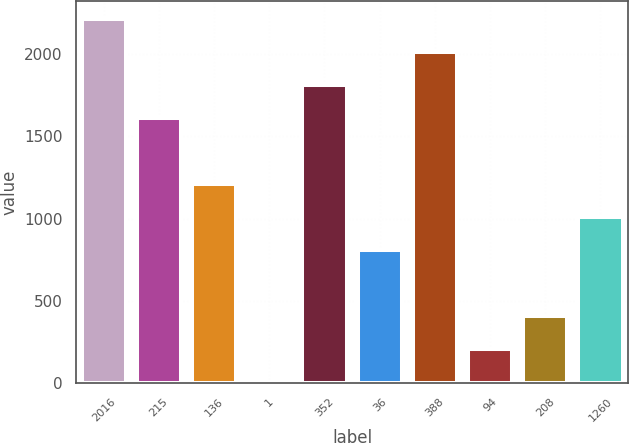<chart> <loc_0><loc_0><loc_500><loc_500><bar_chart><fcel>2016<fcel>215<fcel>136<fcel>1<fcel>352<fcel>36<fcel>388<fcel>94<fcel>208<fcel>1260<nl><fcel>2212.6<fcel>1610.8<fcel>1209.6<fcel>6<fcel>1811.4<fcel>808.4<fcel>2012<fcel>206.6<fcel>407.2<fcel>1009<nl></chart> 